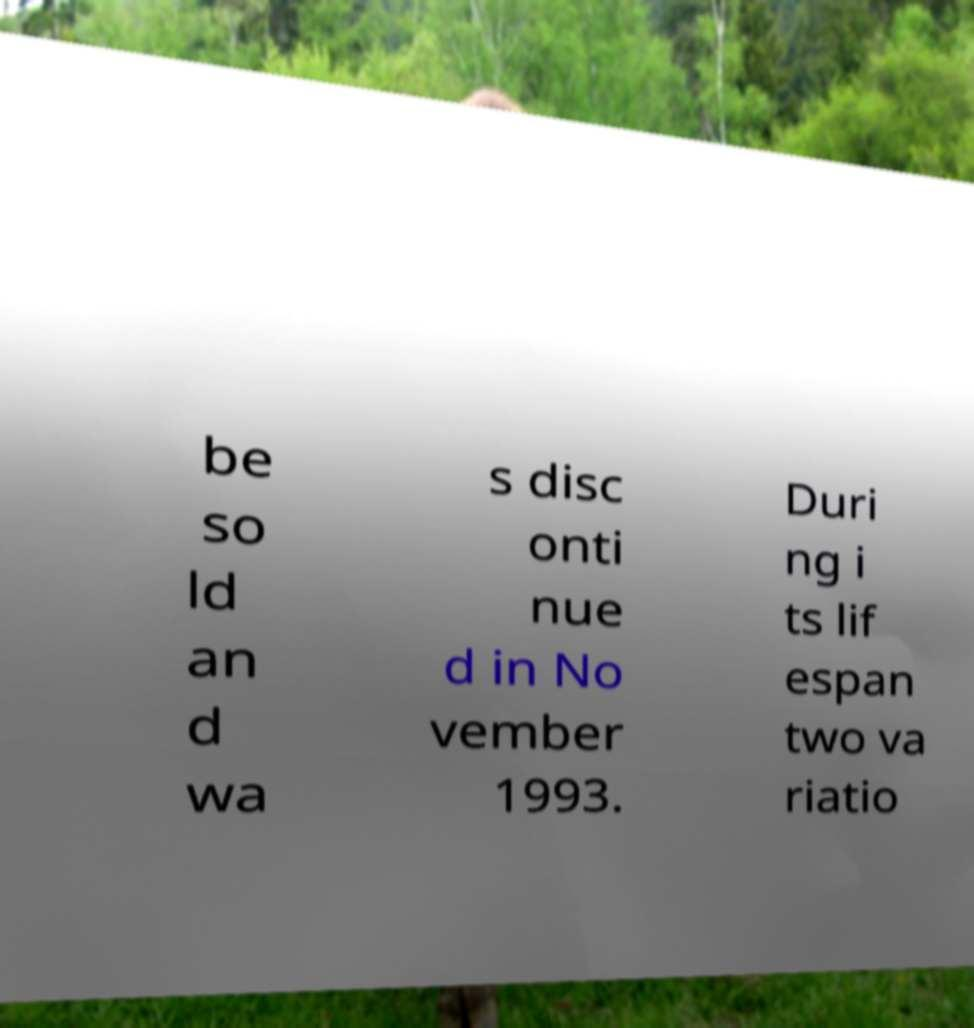Can you accurately transcribe the text from the provided image for me? be so ld an d wa s disc onti nue d in No vember 1993. Duri ng i ts lif espan two va riatio 